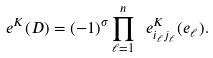Convert formula to latex. <formula><loc_0><loc_0><loc_500><loc_500>\ e ^ { K } ( D ) = ( - 1 ) ^ { \sigma } \prod _ { \ell = 1 } ^ { n } \ e ^ { K } _ { i _ { \ell } j _ { \ell } } ( e _ { \ell } ) .</formula> 